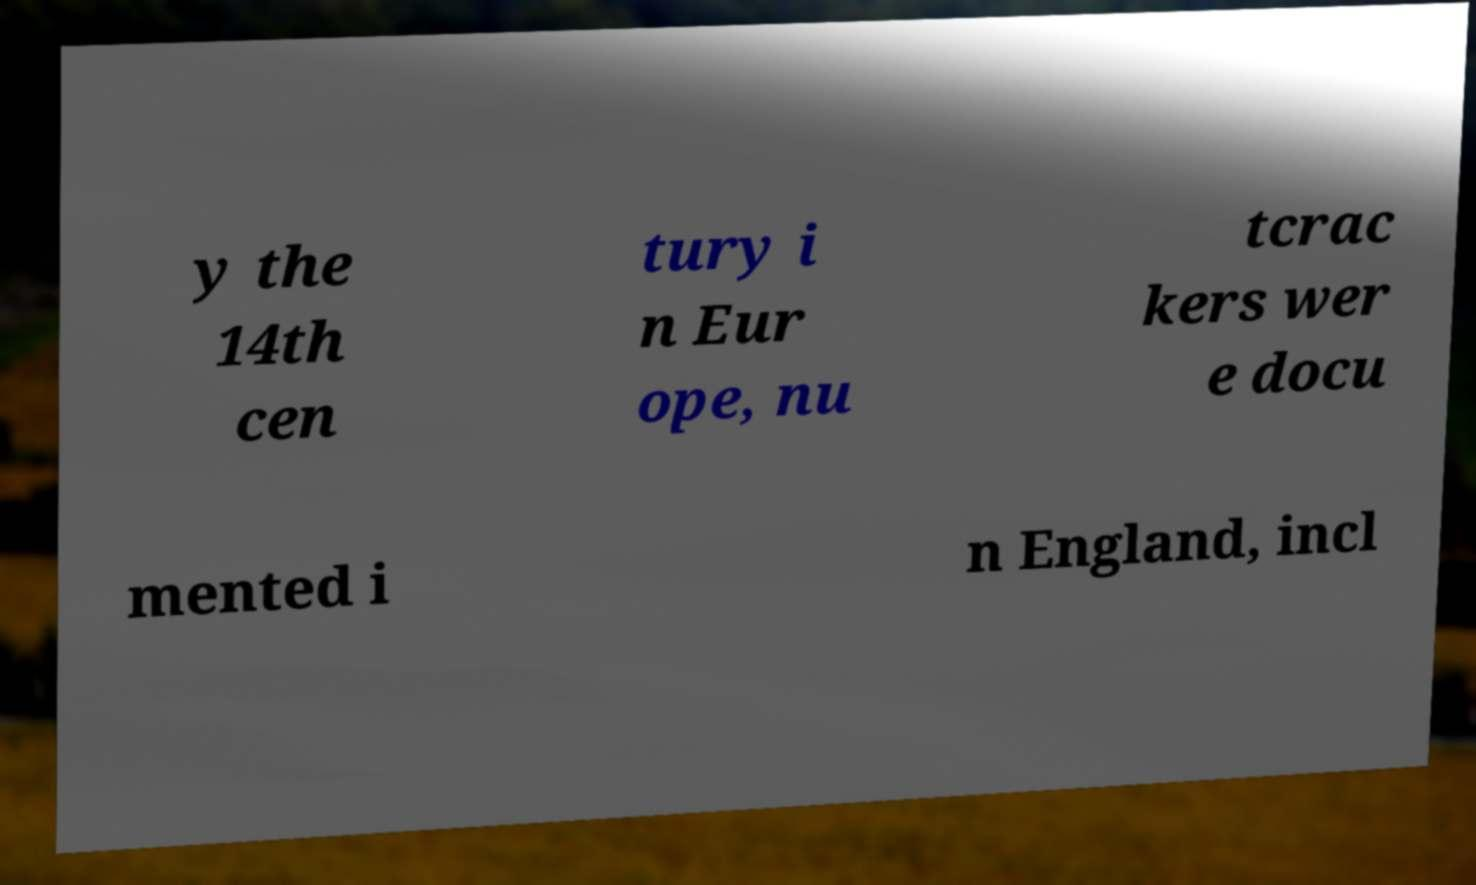What messages or text are displayed in this image? I need them in a readable, typed format. y the 14th cen tury i n Eur ope, nu tcrac kers wer e docu mented i n England, incl 